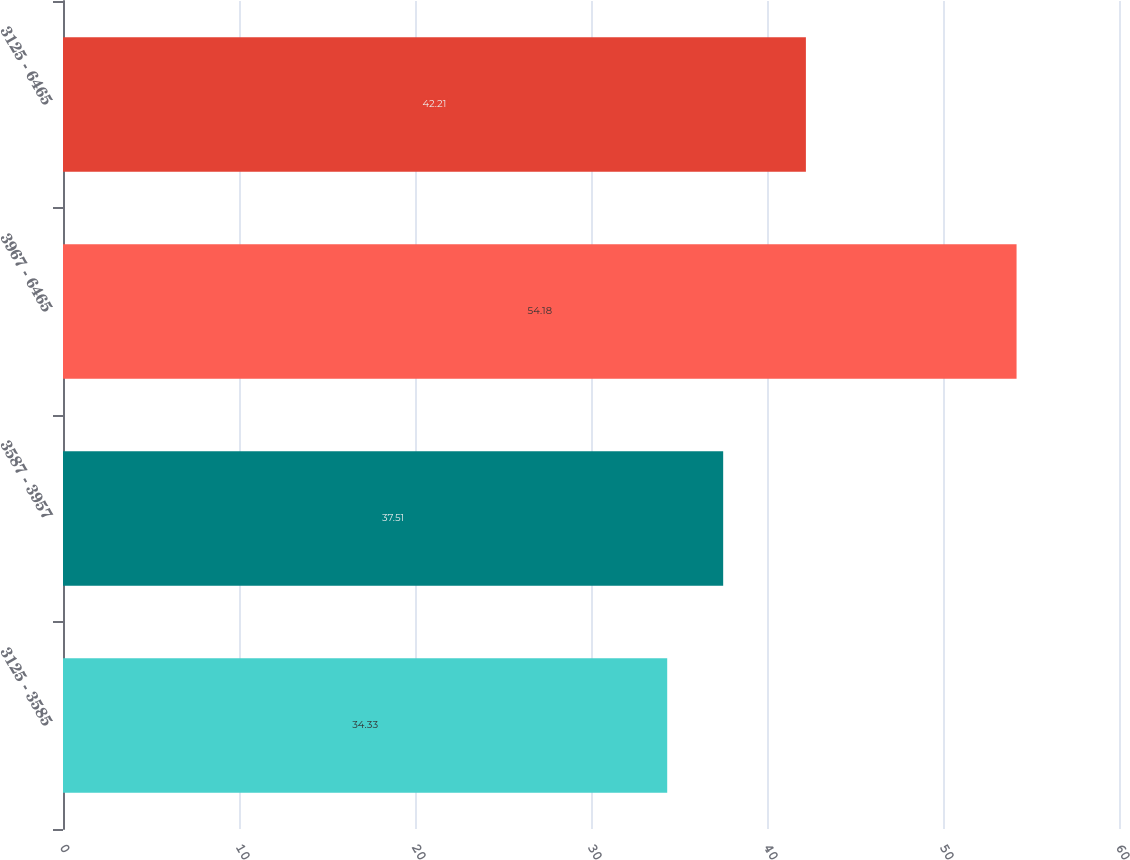Convert chart. <chart><loc_0><loc_0><loc_500><loc_500><bar_chart><fcel>3125 - 3585<fcel>3587 - 3957<fcel>3967 - 6465<fcel>3125 - 6465<nl><fcel>34.33<fcel>37.51<fcel>54.18<fcel>42.21<nl></chart> 